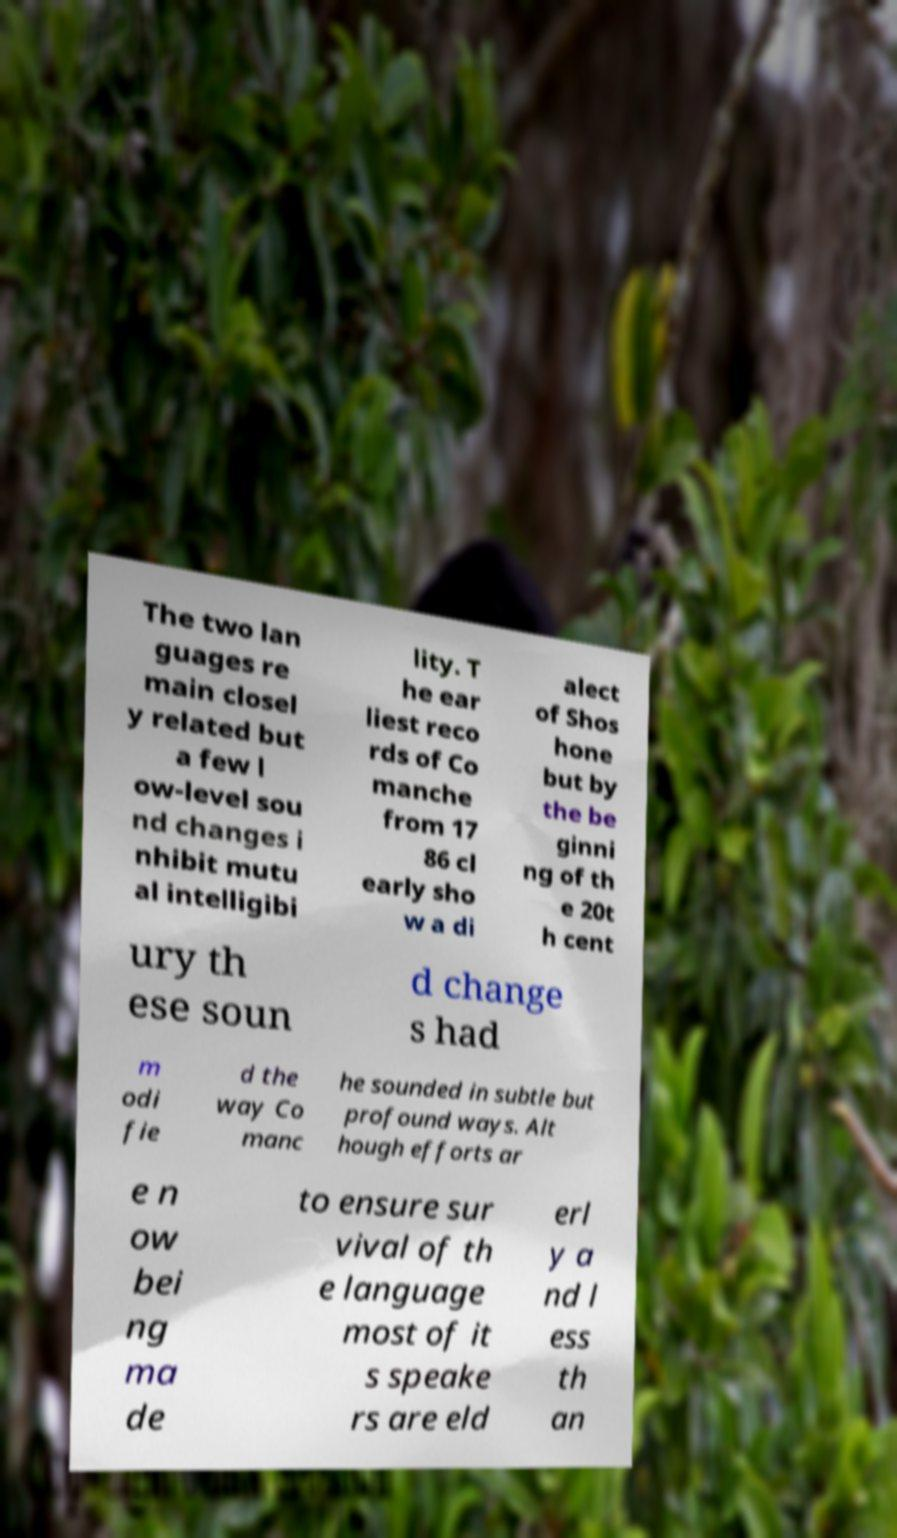There's text embedded in this image that I need extracted. Can you transcribe it verbatim? The two lan guages re main closel y related but a few l ow-level sou nd changes i nhibit mutu al intelligibi lity. T he ear liest reco rds of Co manche from 17 86 cl early sho w a di alect of Shos hone but by the be ginni ng of th e 20t h cent ury th ese soun d change s had m odi fie d the way Co manc he sounded in subtle but profound ways. Alt hough efforts ar e n ow bei ng ma de to ensure sur vival of th e language most of it s speake rs are eld erl y a nd l ess th an 